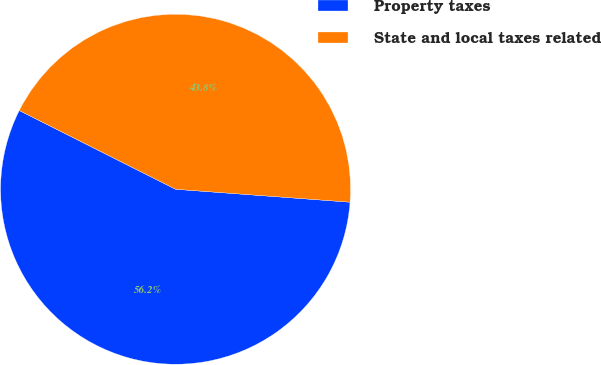<chart> <loc_0><loc_0><loc_500><loc_500><pie_chart><fcel>Property taxes<fcel>State and local taxes related<nl><fcel>56.25%<fcel>43.75%<nl></chart> 